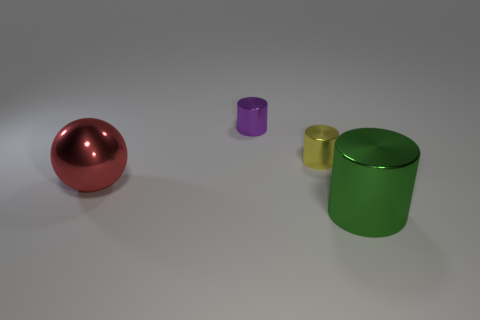There is a tiny thing that is left of the small yellow shiny object; is it the same color as the big metal object to the left of the green thing?
Your response must be concise. No. There is a big thing that is in front of the metallic object that is left of the purple metallic cylinder; what is its shape?
Provide a short and direct response. Cylinder. Do the tiny cylinder behind the yellow metallic thing and the large thing behind the green metal thing have the same material?
Offer a terse response. Yes. There is a metallic thing to the left of the purple metal thing; what size is it?
Make the answer very short. Large. What is the material of the purple thing that is the same shape as the tiny yellow object?
Make the answer very short. Metal. Are there any other things that have the same size as the red metallic thing?
Your answer should be very brief. Yes. There is a large object behind the large green cylinder; what shape is it?
Your answer should be compact. Sphere. How many other tiny green rubber things have the same shape as the green object?
Provide a succinct answer. 0. Are there the same number of big red balls that are right of the purple shiny object and spheres that are to the right of the green metal cylinder?
Your response must be concise. Yes. Is there a tiny green object that has the same material as the small yellow cylinder?
Make the answer very short. No. 